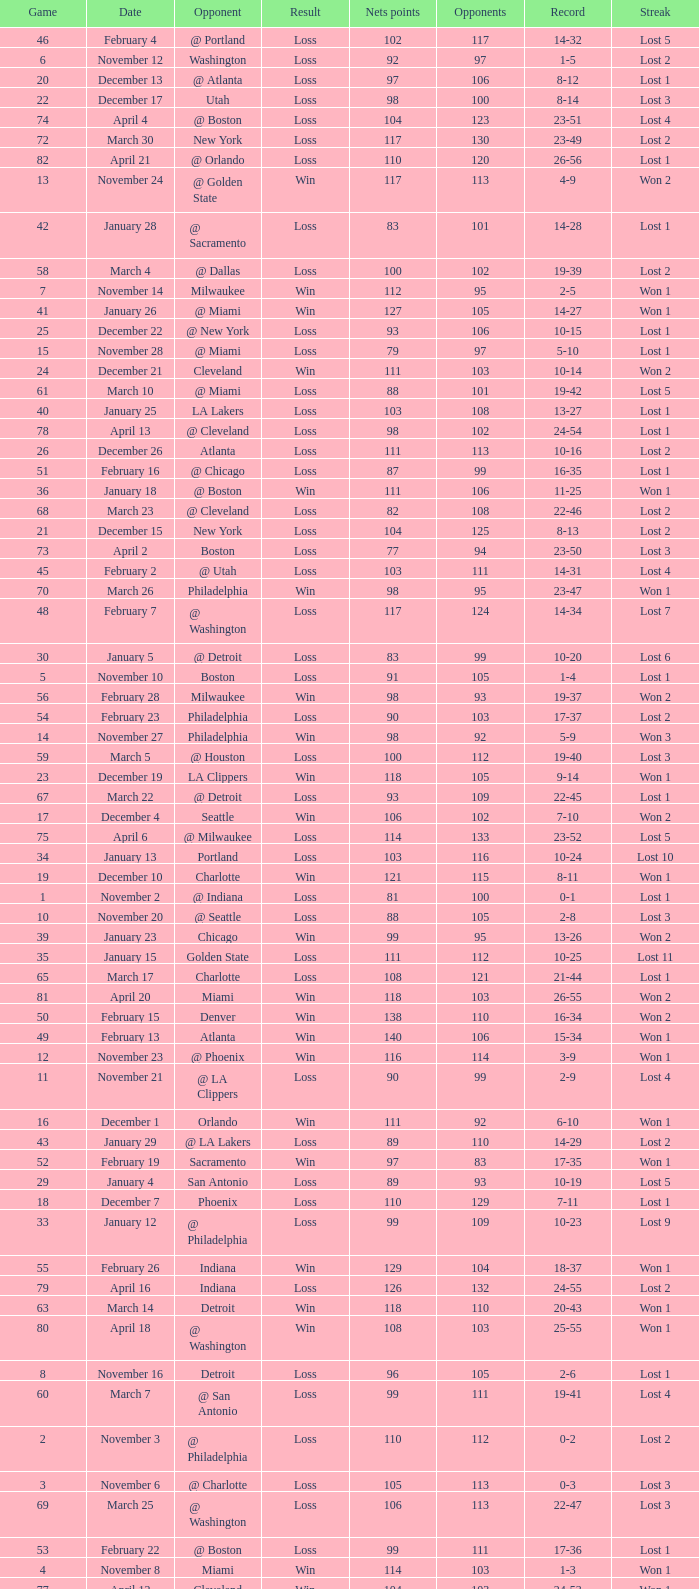In which game did the opponent score more than 103 and the record was 1-3? None. 